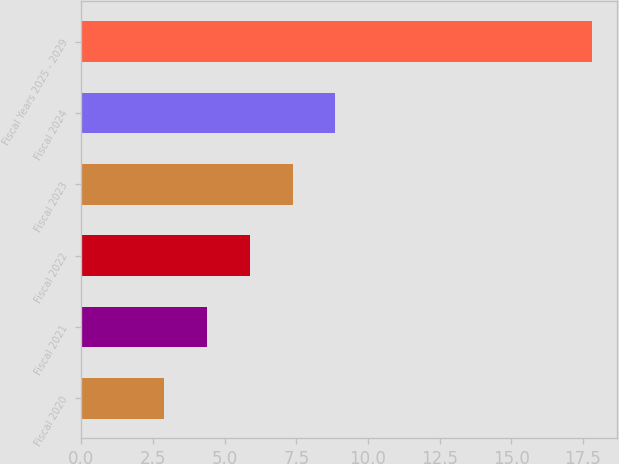Convert chart. <chart><loc_0><loc_0><loc_500><loc_500><bar_chart><fcel>Fiscal 2020<fcel>Fiscal 2021<fcel>Fiscal 2022<fcel>Fiscal 2023<fcel>Fiscal 2024<fcel>Fiscal Years 2025 - 2029<nl><fcel>2.9<fcel>4.39<fcel>5.88<fcel>7.37<fcel>8.86<fcel>17.8<nl></chart> 